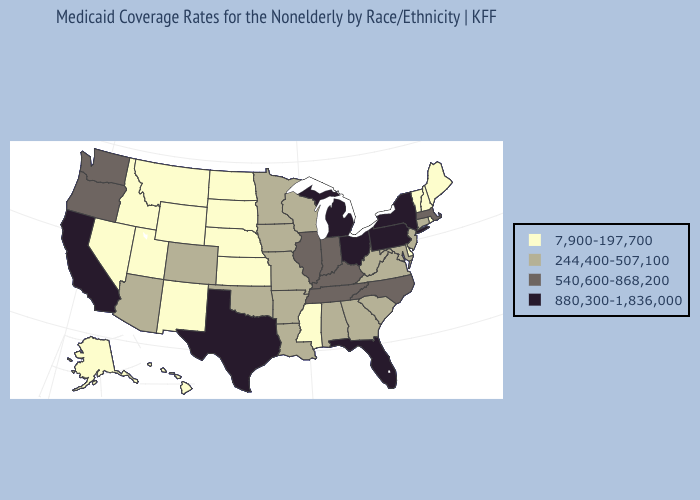Among the states that border New Hampshire , which have the lowest value?
Concise answer only. Maine, Vermont. Does California have a higher value than Florida?
Keep it brief. No. Does Iowa have the lowest value in the USA?
Be succinct. No. Name the states that have a value in the range 540,600-868,200?
Concise answer only. Illinois, Indiana, Kentucky, Massachusetts, North Carolina, Oregon, Tennessee, Washington. Does the map have missing data?
Concise answer only. No. Which states have the lowest value in the South?
Answer briefly. Delaware, Mississippi. Name the states that have a value in the range 540,600-868,200?
Be succinct. Illinois, Indiana, Kentucky, Massachusetts, North Carolina, Oregon, Tennessee, Washington. What is the highest value in states that border Delaware?
Quick response, please. 880,300-1,836,000. Name the states that have a value in the range 7,900-197,700?
Answer briefly. Alaska, Delaware, Hawaii, Idaho, Kansas, Maine, Mississippi, Montana, Nebraska, Nevada, New Hampshire, New Mexico, North Dakota, Rhode Island, South Dakota, Utah, Vermont, Wyoming. Which states hav the highest value in the West?
Give a very brief answer. California. What is the highest value in states that border Oregon?
Short answer required. 880,300-1,836,000. Does Hawaii have the lowest value in the USA?
Answer briefly. Yes. Does South Dakota have the same value as West Virginia?
Short answer required. No. Name the states that have a value in the range 540,600-868,200?
Answer briefly. Illinois, Indiana, Kentucky, Massachusetts, North Carolina, Oregon, Tennessee, Washington. Does Mississippi have the lowest value in the South?
Keep it brief. Yes. 